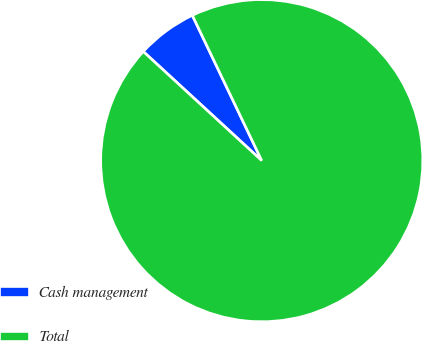Convert chart to OTSL. <chart><loc_0><loc_0><loc_500><loc_500><pie_chart><fcel>Cash management<fcel>Total<nl><fcel>6.06%<fcel>93.94%<nl></chart> 